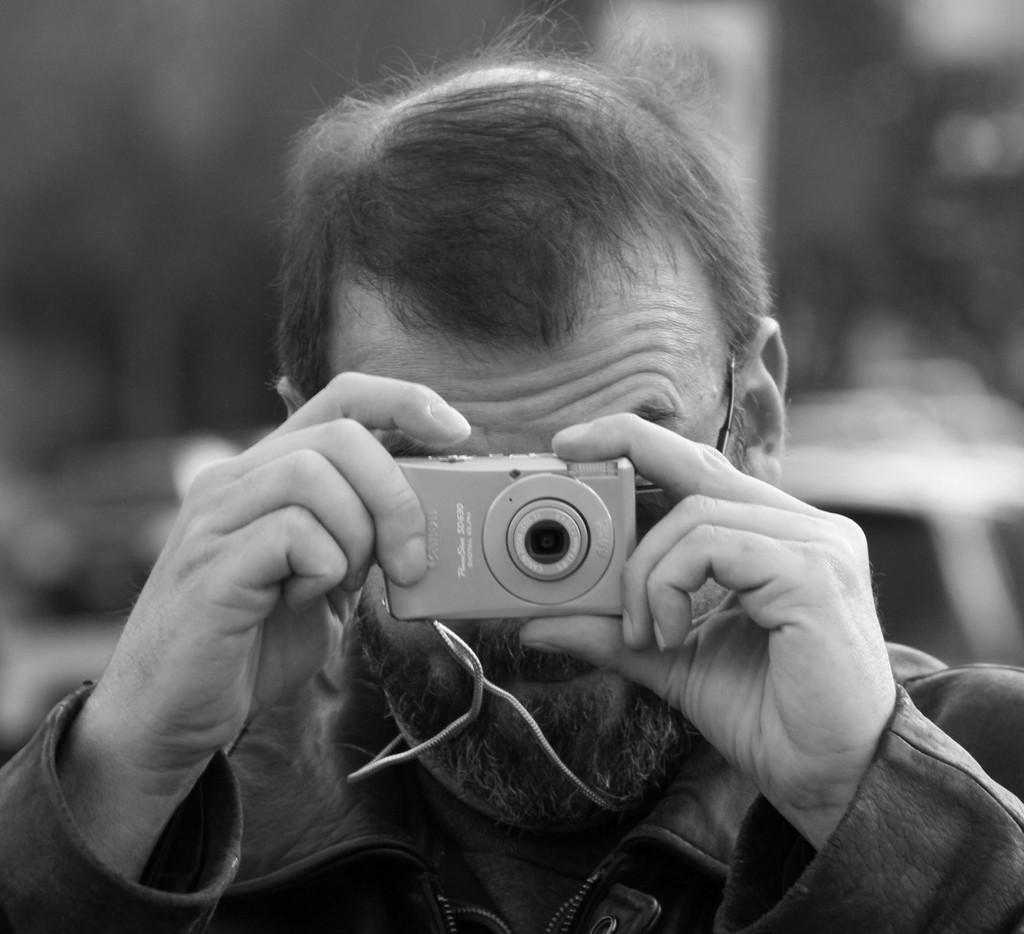Could you give a brief overview of what you see in this image? In this picture we can see man holding camera in his hand and taking picture and in background we can see some vehicles and it is blurry. 